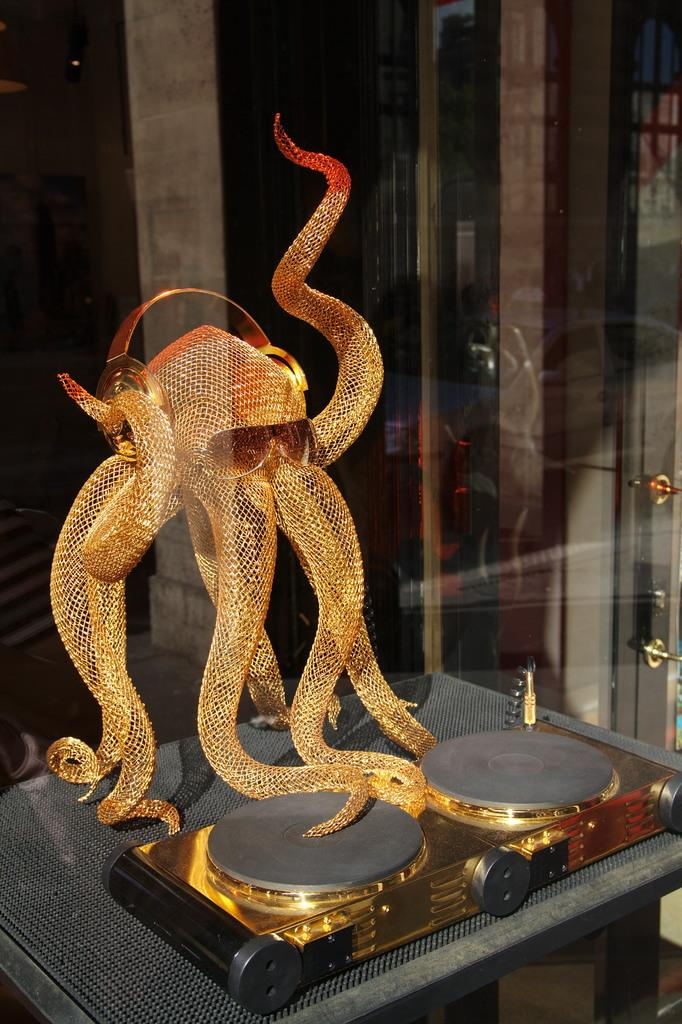What is the main subject of the image? The main subject of the image is an octopus-like object. What features does the object have? The object has goggles and a headset. Where is the object located in the image? The object is in a display. How is the display protected in the image? The display is surrounded by glass. How many pizzas are being served in the image? There are no pizzas present in the image. Can you tell me how many people are using the lift in the image? There is no lift present in the image. 